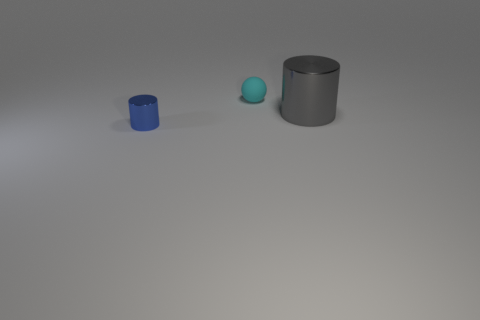What number of objects are on the left side of the gray shiny cylinder and on the right side of the tiny blue thing?
Offer a very short reply. 1. What is the material of the small cyan object?
Ensure brevity in your answer.  Rubber. Are there an equal number of big things that are in front of the large gray metallic cylinder and large purple rubber spheres?
Provide a short and direct response. Yes. What number of other big metal things are the same shape as the blue thing?
Your answer should be compact. 1. Do the small cyan matte thing and the gray metallic thing have the same shape?
Ensure brevity in your answer.  No. What number of things are metallic cylinders left of the large gray shiny cylinder or gray things?
Offer a very short reply. 2. What shape is the metal object that is behind the tiny thing that is in front of the cylinder that is behind the small blue thing?
Ensure brevity in your answer.  Cylinder. What is the shape of the small thing that is the same material as the big cylinder?
Give a very brief answer. Cylinder. What is the size of the cyan sphere?
Provide a succinct answer. Small. Does the cyan object have the same size as the blue metallic cylinder?
Keep it short and to the point. Yes. 